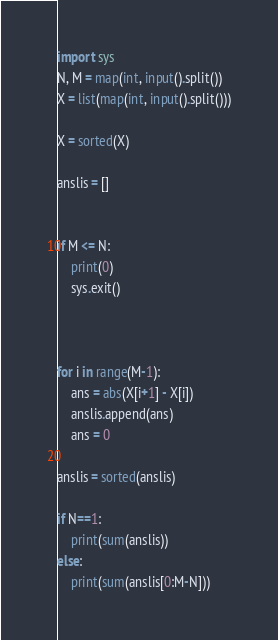Convert code to text. <code><loc_0><loc_0><loc_500><loc_500><_Python_>import sys 
N, M = map(int, input().split())
X = list(map(int, input().split()))

X = sorted(X)

anslis = []


if M <= N:
    print(0)
    sys.exit()


    
for i in range(M-1):
    ans = abs(X[i+1] - X[i])
    anslis.append(ans)
    ans = 0

anslis = sorted(anslis)

if N==1:
    print(sum(anslis))
else:
    print(sum(anslis[0:M-N]))</code> 